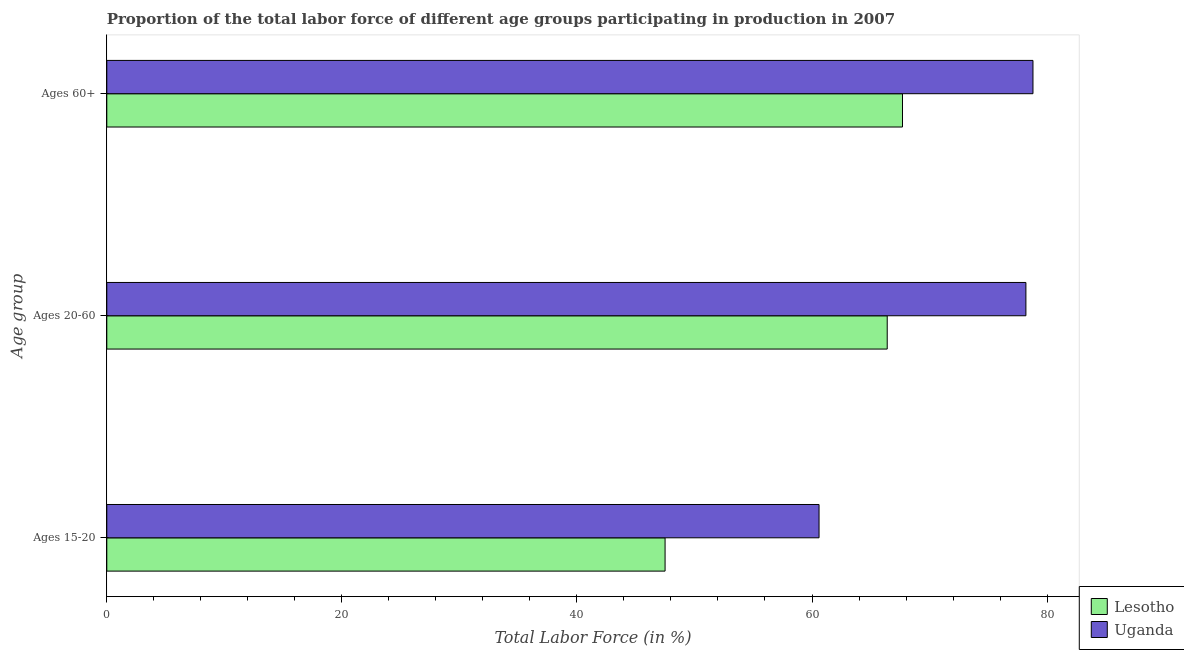What is the label of the 3rd group of bars from the top?
Give a very brief answer. Ages 15-20. What is the percentage of labor force within the age group 20-60 in Lesotho?
Give a very brief answer. 66.4. Across all countries, what is the maximum percentage of labor force above age 60?
Your response must be concise. 78.8. Across all countries, what is the minimum percentage of labor force within the age group 15-20?
Ensure brevity in your answer.  47.5. In which country was the percentage of labor force within the age group 15-20 maximum?
Provide a short and direct response. Uganda. In which country was the percentage of labor force within the age group 15-20 minimum?
Make the answer very short. Lesotho. What is the total percentage of labor force within the age group 15-20 in the graph?
Give a very brief answer. 108.1. What is the difference between the percentage of labor force above age 60 in Uganda and that in Lesotho?
Give a very brief answer. 11.1. What is the difference between the percentage of labor force within the age group 20-60 in Uganda and the percentage of labor force above age 60 in Lesotho?
Give a very brief answer. 10.5. What is the average percentage of labor force above age 60 per country?
Provide a succinct answer. 73.25. What is the difference between the percentage of labor force above age 60 and percentage of labor force within the age group 15-20 in Uganda?
Your answer should be compact. 18.2. In how many countries, is the percentage of labor force within the age group 15-20 greater than 4 %?
Offer a terse response. 2. What is the ratio of the percentage of labor force above age 60 in Lesotho to that in Uganda?
Provide a succinct answer. 0.86. Is the percentage of labor force above age 60 in Uganda less than that in Lesotho?
Ensure brevity in your answer.  No. Is the difference between the percentage of labor force within the age group 15-20 in Lesotho and Uganda greater than the difference between the percentage of labor force within the age group 20-60 in Lesotho and Uganda?
Your answer should be compact. No. What is the difference between the highest and the second highest percentage of labor force above age 60?
Your answer should be compact. 11.1. What is the difference between the highest and the lowest percentage of labor force within the age group 20-60?
Keep it short and to the point. 11.8. In how many countries, is the percentage of labor force above age 60 greater than the average percentage of labor force above age 60 taken over all countries?
Provide a succinct answer. 1. What does the 1st bar from the top in Ages 20-60 represents?
Keep it short and to the point. Uganda. What does the 2nd bar from the bottom in Ages 60+ represents?
Your response must be concise. Uganda. Is it the case that in every country, the sum of the percentage of labor force within the age group 15-20 and percentage of labor force within the age group 20-60 is greater than the percentage of labor force above age 60?
Your response must be concise. Yes. Are all the bars in the graph horizontal?
Provide a short and direct response. Yes. How many countries are there in the graph?
Keep it short and to the point. 2. Are the values on the major ticks of X-axis written in scientific E-notation?
Offer a very short reply. No. Where does the legend appear in the graph?
Ensure brevity in your answer.  Bottom right. How are the legend labels stacked?
Offer a very short reply. Vertical. What is the title of the graph?
Your answer should be very brief. Proportion of the total labor force of different age groups participating in production in 2007. What is the label or title of the X-axis?
Give a very brief answer. Total Labor Force (in %). What is the label or title of the Y-axis?
Ensure brevity in your answer.  Age group. What is the Total Labor Force (in %) in Lesotho in Ages 15-20?
Your response must be concise. 47.5. What is the Total Labor Force (in %) of Uganda in Ages 15-20?
Offer a very short reply. 60.6. What is the Total Labor Force (in %) in Lesotho in Ages 20-60?
Offer a very short reply. 66.4. What is the Total Labor Force (in %) in Uganda in Ages 20-60?
Keep it short and to the point. 78.2. What is the Total Labor Force (in %) in Lesotho in Ages 60+?
Make the answer very short. 67.7. What is the Total Labor Force (in %) in Uganda in Ages 60+?
Offer a very short reply. 78.8. Across all Age group, what is the maximum Total Labor Force (in %) in Lesotho?
Provide a short and direct response. 67.7. Across all Age group, what is the maximum Total Labor Force (in %) in Uganda?
Your answer should be very brief. 78.8. Across all Age group, what is the minimum Total Labor Force (in %) of Lesotho?
Your answer should be very brief. 47.5. Across all Age group, what is the minimum Total Labor Force (in %) of Uganda?
Keep it short and to the point. 60.6. What is the total Total Labor Force (in %) of Lesotho in the graph?
Offer a very short reply. 181.6. What is the total Total Labor Force (in %) of Uganda in the graph?
Your response must be concise. 217.6. What is the difference between the Total Labor Force (in %) of Lesotho in Ages 15-20 and that in Ages 20-60?
Your answer should be compact. -18.9. What is the difference between the Total Labor Force (in %) of Uganda in Ages 15-20 and that in Ages 20-60?
Provide a short and direct response. -17.6. What is the difference between the Total Labor Force (in %) of Lesotho in Ages 15-20 and that in Ages 60+?
Ensure brevity in your answer.  -20.2. What is the difference between the Total Labor Force (in %) in Uganda in Ages 15-20 and that in Ages 60+?
Give a very brief answer. -18.2. What is the difference between the Total Labor Force (in %) of Lesotho in Ages 15-20 and the Total Labor Force (in %) of Uganda in Ages 20-60?
Offer a very short reply. -30.7. What is the difference between the Total Labor Force (in %) in Lesotho in Ages 15-20 and the Total Labor Force (in %) in Uganda in Ages 60+?
Make the answer very short. -31.3. What is the average Total Labor Force (in %) of Lesotho per Age group?
Provide a succinct answer. 60.53. What is the average Total Labor Force (in %) of Uganda per Age group?
Your answer should be compact. 72.53. What is the difference between the Total Labor Force (in %) in Lesotho and Total Labor Force (in %) in Uganda in Ages 20-60?
Make the answer very short. -11.8. What is the ratio of the Total Labor Force (in %) of Lesotho in Ages 15-20 to that in Ages 20-60?
Ensure brevity in your answer.  0.72. What is the ratio of the Total Labor Force (in %) in Uganda in Ages 15-20 to that in Ages 20-60?
Keep it short and to the point. 0.77. What is the ratio of the Total Labor Force (in %) of Lesotho in Ages 15-20 to that in Ages 60+?
Provide a short and direct response. 0.7. What is the ratio of the Total Labor Force (in %) in Uganda in Ages 15-20 to that in Ages 60+?
Ensure brevity in your answer.  0.77. What is the ratio of the Total Labor Force (in %) of Lesotho in Ages 20-60 to that in Ages 60+?
Keep it short and to the point. 0.98. What is the difference between the highest and the lowest Total Labor Force (in %) of Lesotho?
Your answer should be very brief. 20.2. 